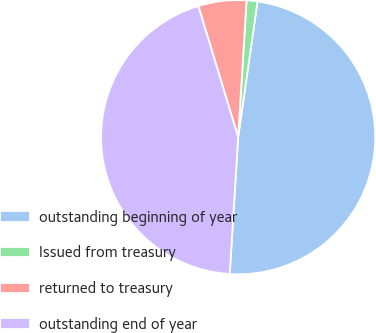Convert chart. <chart><loc_0><loc_0><loc_500><loc_500><pie_chart><fcel>outstanding beginning of year<fcel>Issued from treasury<fcel>returned to treasury<fcel>outstanding end of year<nl><fcel>48.72%<fcel>1.28%<fcel>5.67%<fcel>44.33%<nl></chart> 